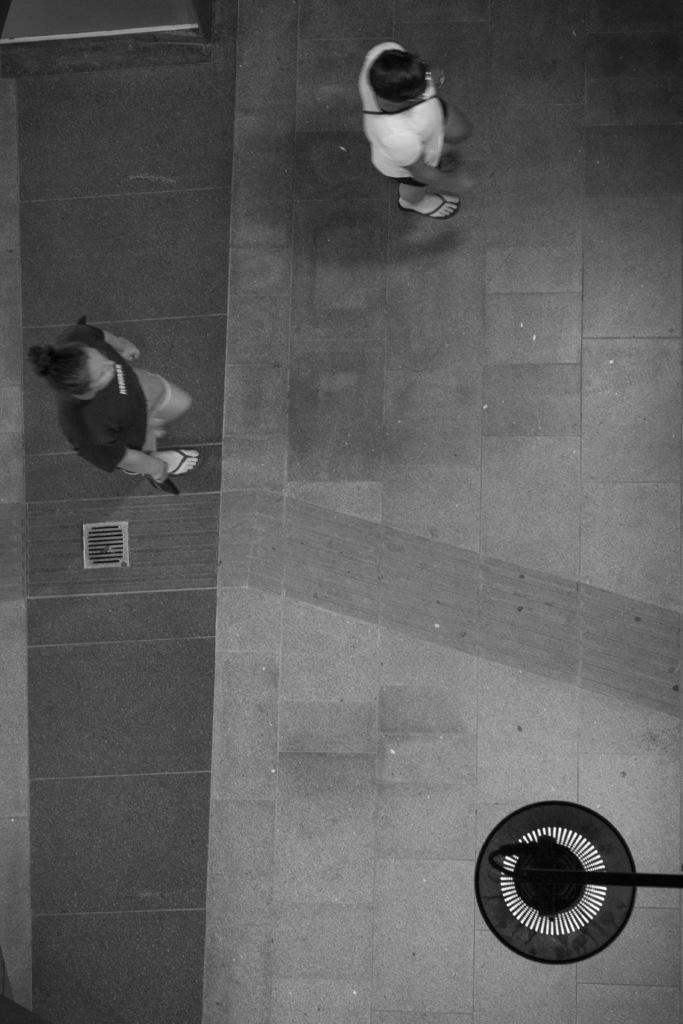How many people are in the image? There are persons in the image, but the exact number is not specified. What are the persons wearing? The persons are wearing clothes. Can you describe the object in the bottom right of the image? Unfortunately, the facts provided do not give any details about the object in the bottom right of the image. How many cows are visible in the image? There are no cows present in the image. What type of net is being used by the persons in the image? There is no mention of a net in the image, so it cannot be determined if one is being used. 